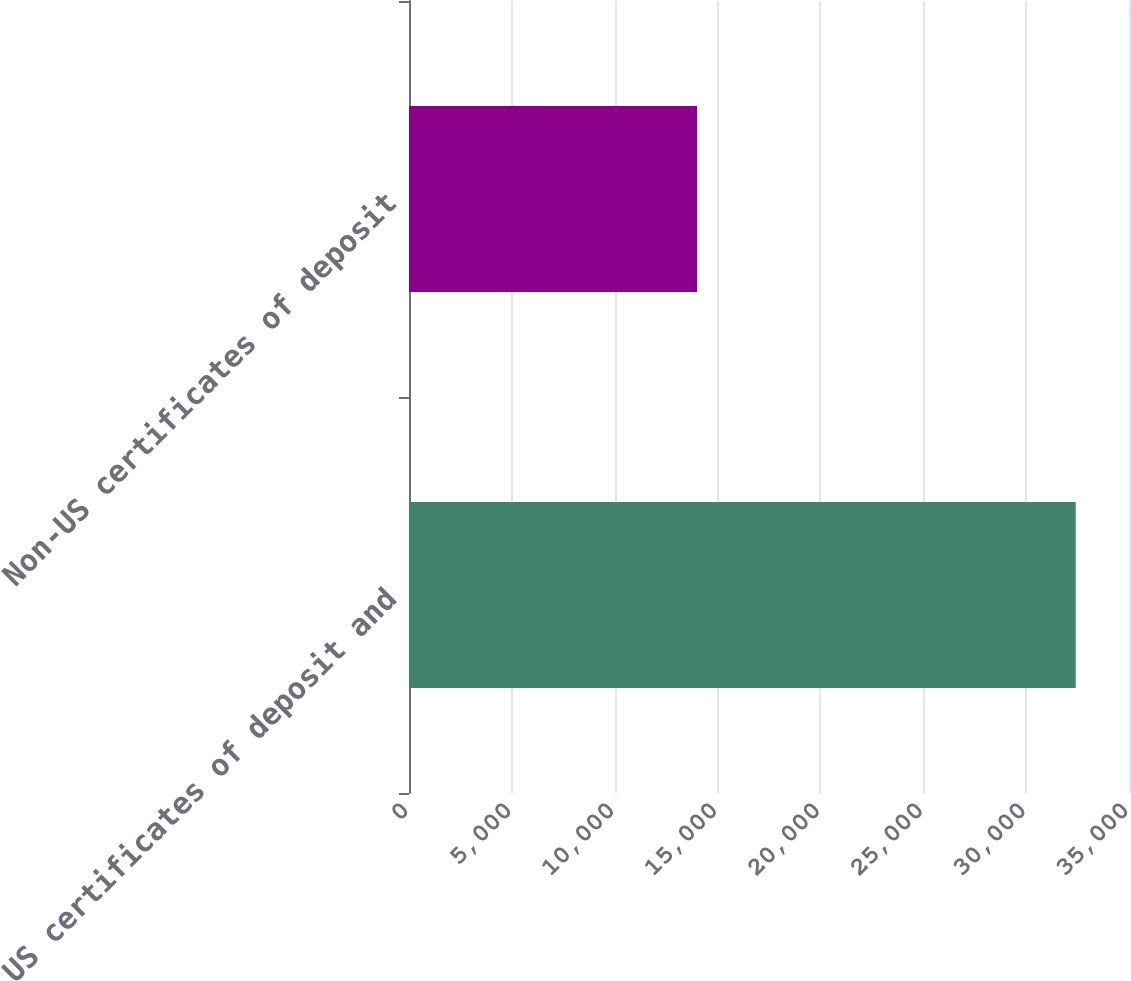<chart> <loc_0><loc_0><loc_500><loc_500><bar_chart><fcel>US certificates of deposit and<fcel>Non-US certificates of deposit<nl><fcel>32409<fcel>14007<nl></chart> 